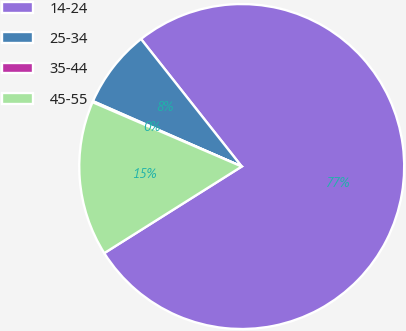Convert chart to OTSL. <chart><loc_0><loc_0><loc_500><loc_500><pie_chart><fcel>14-24<fcel>25-34<fcel>35-44<fcel>45-55<nl><fcel>76.69%<fcel>7.77%<fcel>0.11%<fcel>15.43%<nl></chart> 